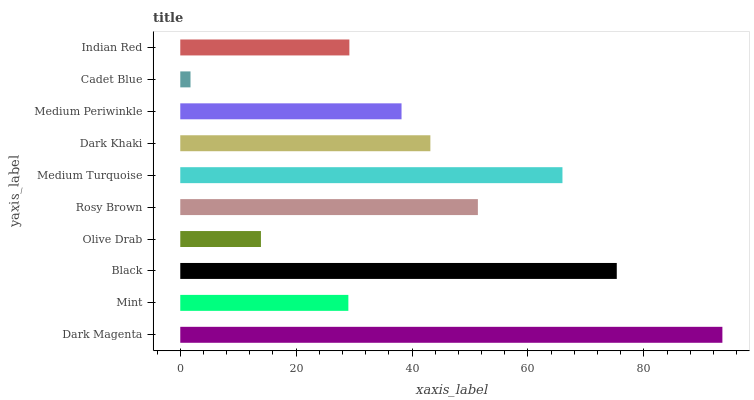Is Cadet Blue the minimum?
Answer yes or no. Yes. Is Dark Magenta the maximum?
Answer yes or no. Yes. Is Mint the minimum?
Answer yes or no. No. Is Mint the maximum?
Answer yes or no. No. Is Dark Magenta greater than Mint?
Answer yes or no. Yes. Is Mint less than Dark Magenta?
Answer yes or no. Yes. Is Mint greater than Dark Magenta?
Answer yes or no. No. Is Dark Magenta less than Mint?
Answer yes or no. No. Is Dark Khaki the high median?
Answer yes or no. Yes. Is Medium Periwinkle the low median?
Answer yes or no. Yes. Is Rosy Brown the high median?
Answer yes or no. No. Is Medium Turquoise the low median?
Answer yes or no. No. 